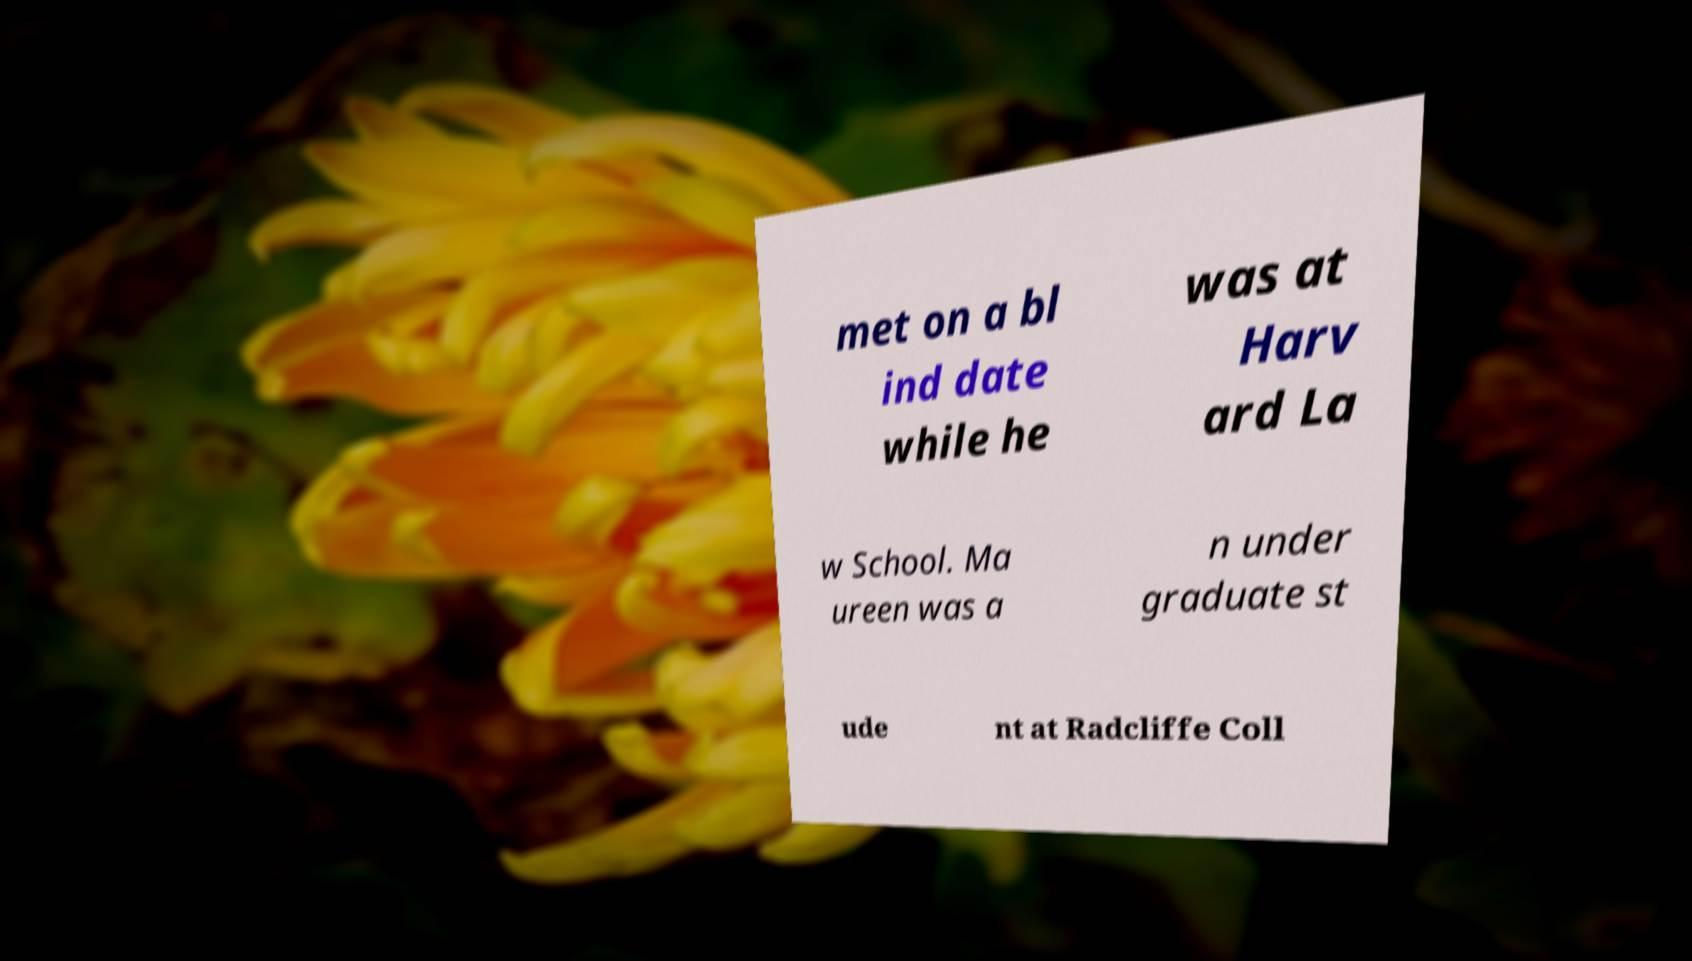Could you extract and type out the text from this image? met on a bl ind date while he was at Harv ard La w School. Ma ureen was a n under graduate st ude nt at Radcliffe Coll 